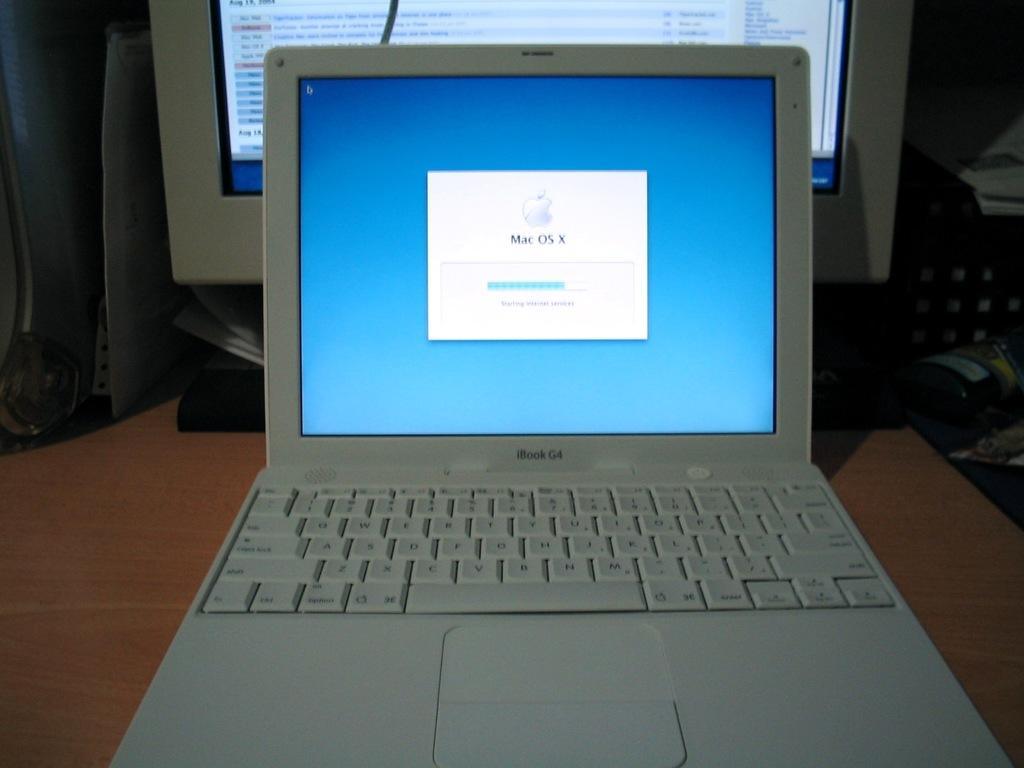<image>
Provide a brief description of the given image. Laptop with a screen that says MAC OS X. 